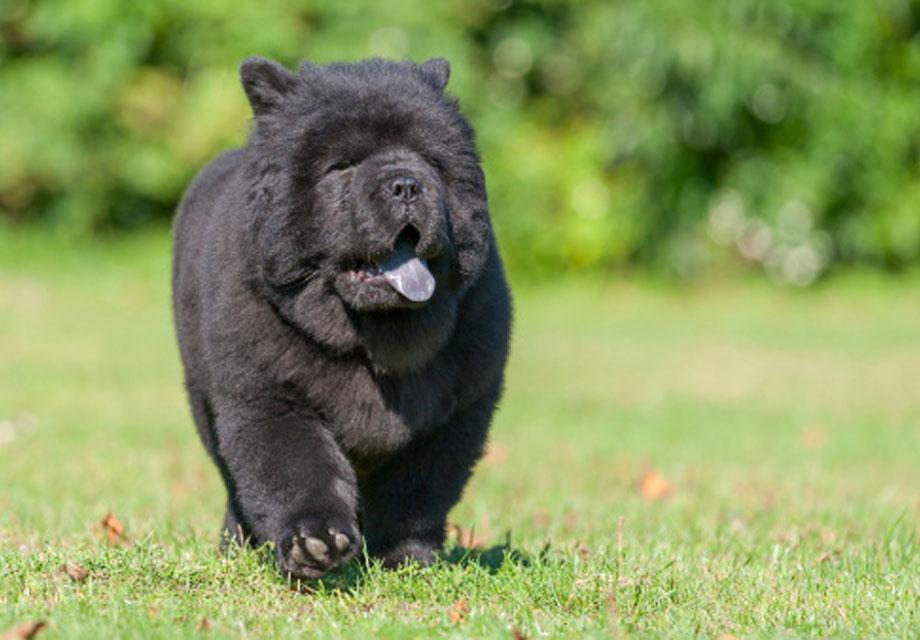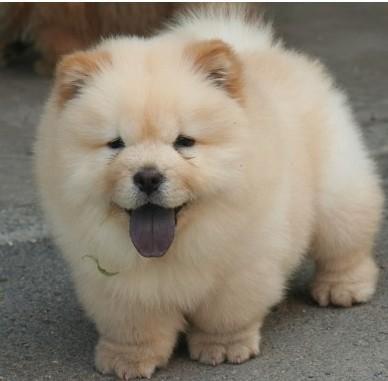The first image is the image on the left, the second image is the image on the right. Analyze the images presented: Is the assertion "One image contains exactly two look-alike chow pups on green grass." valid? Answer yes or no. No. The first image is the image on the left, the second image is the image on the right. For the images shown, is this caption "There are two Chow Chows." true? Answer yes or no. Yes. 